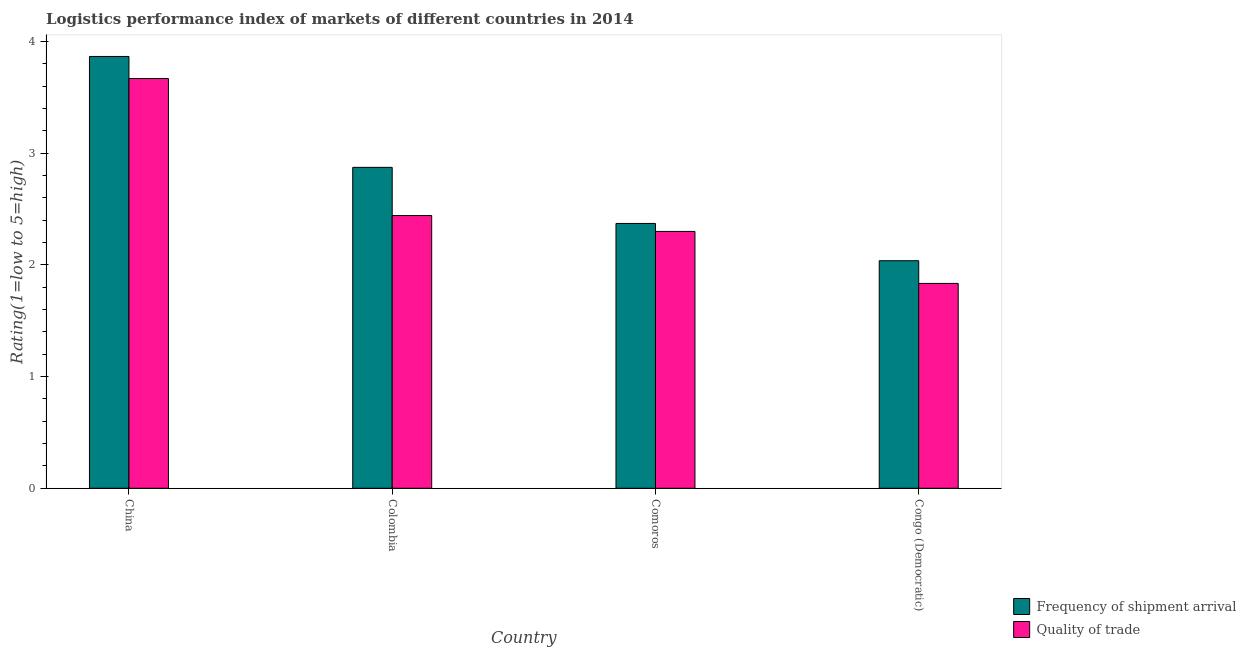How many groups of bars are there?
Make the answer very short. 4. Are the number of bars on each tick of the X-axis equal?
Offer a terse response. Yes. How many bars are there on the 1st tick from the left?
Make the answer very short. 2. How many bars are there on the 4th tick from the right?
Provide a succinct answer. 2. What is the label of the 3rd group of bars from the left?
Provide a succinct answer. Comoros. In how many cases, is the number of bars for a given country not equal to the number of legend labels?
Your response must be concise. 0. What is the lpi quality of trade in China?
Make the answer very short. 3.67. Across all countries, what is the maximum lpi quality of trade?
Offer a very short reply. 3.67. Across all countries, what is the minimum lpi of frequency of shipment arrival?
Your response must be concise. 2.04. In which country was the lpi of frequency of shipment arrival maximum?
Your answer should be very brief. China. In which country was the lpi quality of trade minimum?
Your response must be concise. Congo (Democratic). What is the total lpi quality of trade in the graph?
Ensure brevity in your answer.  10.25. What is the difference between the lpi of frequency of shipment arrival in Colombia and that in Congo (Democratic)?
Make the answer very short. 0.84. What is the difference between the lpi quality of trade in China and the lpi of frequency of shipment arrival in Colombia?
Give a very brief answer. 0.8. What is the average lpi of frequency of shipment arrival per country?
Your answer should be compact. 2.79. What is the difference between the lpi quality of trade and lpi of frequency of shipment arrival in China?
Ensure brevity in your answer.  -0.2. What is the ratio of the lpi quality of trade in Comoros to that in Congo (Democratic)?
Your response must be concise. 1.25. What is the difference between the highest and the second highest lpi quality of trade?
Offer a terse response. 1.23. What is the difference between the highest and the lowest lpi of frequency of shipment arrival?
Your answer should be very brief. 1.83. Is the sum of the lpi of frequency of shipment arrival in China and Colombia greater than the maximum lpi quality of trade across all countries?
Offer a terse response. Yes. What does the 1st bar from the left in Comoros represents?
Make the answer very short. Frequency of shipment arrival. What does the 2nd bar from the right in China represents?
Your answer should be compact. Frequency of shipment arrival. Are the values on the major ticks of Y-axis written in scientific E-notation?
Offer a terse response. No. Does the graph contain any zero values?
Give a very brief answer. No. How many legend labels are there?
Your answer should be compact. 2. What is the title of the graph?
Provide a succinct answer. Logistics performance index of markets of different countries in 2014. What is the label or title of the Y-axis?
Make the answer very short. Rating(1=low to 5=high). What is the Rating(1=low to 5=high) of Frequency of shipment arrival in China?
Ensure brevity in your answer.  3.87. What is the Rating(1=low to 5=high) in Quality of trade in China?
Your response must be concise. 3.67. What is the Rating(1=low to 5=high) of Frequency of shipment arrival in Colombia?
Offer a terse response. 2.87. What is the Rating(1=low to 5=high) of Quality of trade in Colombia?
Ensure brevity in your answer.  2.44. What is the Rating(1=low to 5=high) in Frequency of shipment arrival in Comoros?
Your response must be concise. 2.37. What is the Rating(1=low to 5=high) of Frequency of shipment arrival in Congo (Democratic)?
Your answer should be very brief. 2.04. What is the Rating(1=low to 5=high) of Quality of trade in Congo (Democratic)?
Your response must be concise. 1.83. Across all countries, what is the maximum Rating(1=low to 5=high) in Frequency of shipment arrival?
Your answer should be very brief. 3.87. Across all countries, what is the maximum Rating(1=low to 5=high) of Quality of trade?
Offer a very short reply. 3.67. Across all countries, what is the minimum Rating(1=low to 5=high) in Frequency of shipment arrival?
Your answer should be very brief. 2.04. Across all countries, what is the minimum Rating(1=low to 5=high) in Quality of trade?
Your answer should be very brief. 1.83. What is the total Rating(1=low to 5=high) of Frequency of shipment arrival in the graph?
Give a very brief answer. 11.15. What is the total Rating(1=low to 5=high) in Quality of trade in the graph?
Provide a short and direct response. 10.25. What is the difference between the Rating(1=low to 5=high) of Frequency of shipment arrival in China and that in Colombia?
Provide a short and direct response. 0.99. What is the difference between the Rating(1=low to 5=high) of Quality of trade in China and that in Colombia?
Keep it short and to the point. 1.23. What is the difference between the Rating(1=low to 5=high) in Frequency of shipment arrival in China and that in Comoros?
Your answer should be compact. 1.5. What is the difference between the Rating(1=low to 5=high) in Quality of trade in China and that in Comoros?
Keep it short and to the point. 1.37. What is the difference between the Rating(1=low to 5=high) of Frequency of shipment arrival in China and that in Congo (Democratic)?
Your answer should be compact. 1.83. What is the difference between the Rating(1=low to 5=high) in Quality of trade in China and that in Congo (Democratic)?
Offer a terse response. 1.83. What is the difference between the Rating(1=low to 5=high) in Frequency of shipment arrival in Colombia and that in Comoros?
Give a very brief answer. 0.5. What is the difference between the Rating(1=low to 5=high) in Quality of trade in Colombia and that in Comoros?
Provide a short and direct response. 0.14. What is the difference between the Rating(1=low to 5=high) of Frequency of shipment arrival in Colombia and that in Congo (Democratic)?
Your answer should be compact. 0.84. What is the difference between the Rating(1=low to 5=high) of Quality of trade in Colombia and that in Congo (Democratic)?
Your response must be concise. 0.61. What is the difference between the Rating(1=low to 5=high) in Frequency of shipment arrival in Comoros and that in Congo (Democratic)?
Ensure brevity in your answer.  0.33. What is the difference between the Rating(1=low to 5=high) in Quality of trade in Comoros and that in Congo (Democratic)?
Give a very brief answer. 0.47. What is the difference between the Rating(1=low to 5=high) in Frequency of shipment arrival in China and the Rating(1=low to 5=high) in Quality of trade in Colombia?
Keep it short and to the point. 1.42. What is the difference between the Rating(1=low to 5=high) of Frequency of shipment arrival in China and the Rating(1=low to 5=high) of Quality of trade in Comoros?
Your response must be concise. 1.57. What is the difference between the Rating(1=low to 5=high) of Frequency of shipment arrival in China and the Rating(1=low to 5=high) of Quality of trade in Congo (Democratic)?
Offer a very short reply. 2.03. What is the difference between the Rating(1=low to 5=high) in Frequency of shipment arrival in Colombia and the Rating(1=low to 5=high) in Quality of trade in Comoros?
Your answer should be very brief. 0.57. What is the difference between the Rating(1=low to 5=high) in Frequency of shipment arrival in Colombia and the Rating(1=low to 5=high) in Quality of trade in Congo (Democratic)?
Ensure brevity in your answer.  1.04. What is the difference between the Rating(1=low to 5=high) in Frequency of shipment arrival in Comoros and the Rating(1=low to 5=high) in Quality of trade in Congo (Democratic)?
Your response must be concise. 0.54. What is the average Rating(1=low to 5=high) of Frequency of shipment arrival per country?
Give a very brief answer. 2.79. What is the average Rating(1=low to 5=high) in Quality of trade per country?
Your answer should be compact. 2.56. What is the difference between the Rating(1=low to 5=high) of Frequency of shipment arrival and Rating(1=low to 5=high) of Quality of trade in China?
Offer a terse response. 0.2. What is the difference between the Rating(1=low to 5=high) of Frequency of shipment arrival and Rating(1=low to 5=high) of Quality of trade in Colombia?
Provide a short and direct response. 0.43. What is the difference between the Rating(1=low to 5=high) in Frequency of shipment arrival and Rating(1=low to 5=high) in Quality of trade in Comoros?
Offer a very short reply. 0.07. What is the difference between the Rating(1=low to 5=high) in Frequency of shipment arrival and Rating(1=low to 5=high) in Quality of trade in Congo (Democratic)?
Your answer should be compact. 0.2. What is the ratio of the Rating(1=low to 5=high) in Frequency of shipment arrival in China to that in Colombia?
Offer a very short reply. 1.35. What is the ratio of the Rating(1=low to 5=high) of Quality of trade in China to that in Colombia?
Give a very brief answer. 1.5. What is the ratio of the Rating(1=low to 5=high) in Frequency of shipment arrival in China to that in Comoros?
Your answer should be compact. 1.63. What is the ratio of the Rating(1=low to 5=high) in Quality of trade in China to that in Comoros?
Provide a short and direct response. 1.6. What is the ratio of the Rating(1=low to 5=high) in Frequency of shipment arrival in China to that in Congo (Democratic)?
Give a very brief answer. 1.9. What is the ratio of the Rating(1=low to 5=high) in Quality of trade in China to that in Congo (Democratic)?
Provide a succinct answer. 2. What is the ratio of the Rating(1=low to 5=high) in Frequency of shipment arrival in Colombia to that in Comoros?
Your response must be concise. 1.21. What is the ratio of the Rating(1=low to 5=high) in Quality of trade in Colombia to that in Comoros?
Offer a terse response. 1.06. What is the ratio of the Rating(1=low to 5=high) of Frequency of shipment arrival in Colombia to that in Congo (Democratic)?
Give a very brief answer. 1.41. What is the ratio of the Rating(1=low to 5=high) in Quality of trade in Colombia to that in Congo (Democratic)?
Provide a succinct answer. 1.33. What is the ratio of the Rating(1=low to 5=high) of Frequency of shipment arrival in Comoros to that in Congo (Democratic)?
Your answer should be very brief. 1.16. What is the ratio of the Rating(1=low to 5=high) of Quality of trade in Comoros to that in Congo (Democratic)?
Make the answer very short. 1.25. What is the difference between the highest and the second highest Rating(1=low to 5=high) in Quality of trade?
Keep it short and to the point. 1.23. What is the difference between the highest and the lowest Rating(1=low to 5=high) in Frequency of shipment arrival?
Keep it short and to the point. 1.83. What is the difference between the highest and the lowest Rating(1=low to 5=high) of Quality of trade?
Provide a succinct answer. 1.83. 